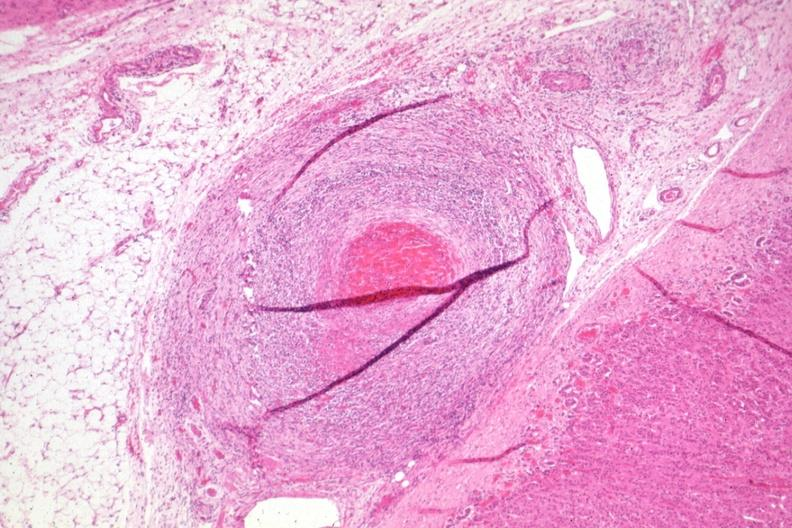has outside adrenal capsule section folds?
Answer the question using a single word or phrase. Yes 